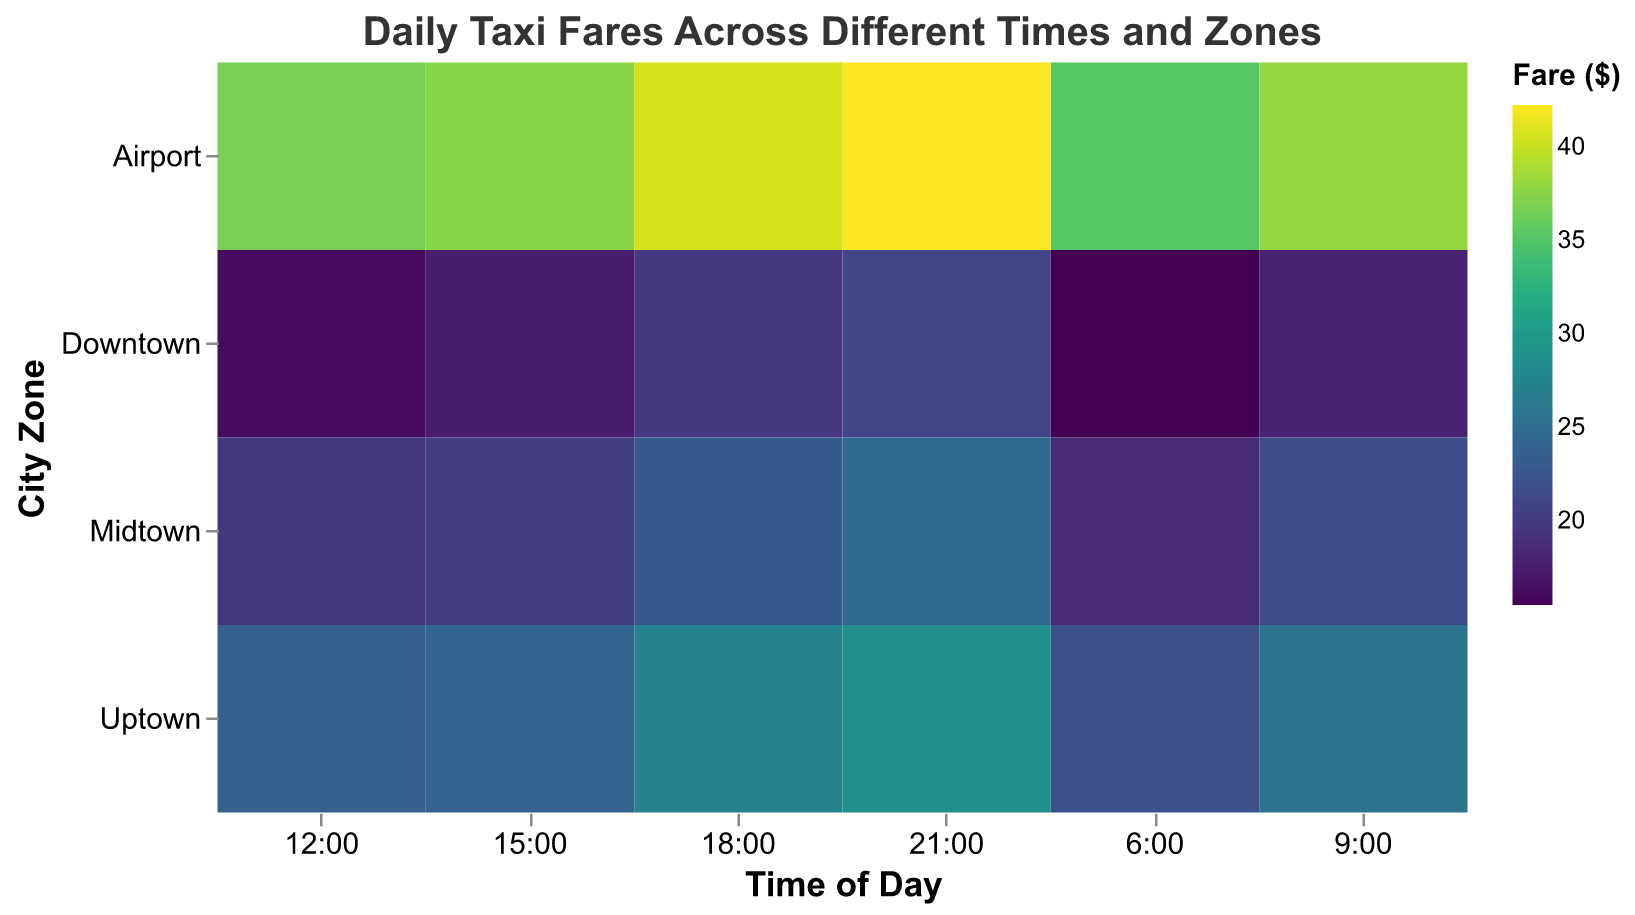What is the title of the figure? The title is usually placed at the top of the chart. In this figure, it is written as "Daily Taxi Fares Across Different Times and Zones."
Answer: Daily Taxi Fares Across Different Times and Zones How many time points are included in the data? Look at the X-axis, which represents the time of day; these time points are: 6:00, 9:00, 12:00, 15:00, 18:00, and 21:00. Count these points.
Answer: 6 Which time period has the highest fare in the Airport zone? In the Y-axis zones, search for "Airport," then across the X-axis time slots, find the highest fare number in the "Airport" row. The highest value is 42.25 at 21:00.
Answer: 21:00 What is the difference in fares between Downtown and Midtown at 18:00? Identify the fares for Downtown and Midtown at 18:00. Downtown is $19.75, Midtown is $23.00. The difference is $23.00 - $19.75.
Answer: 3.25 At what time of day is the fare highest for the Uptown zone? Scan the Uptown row's fare values for all time points and identify the highest. The highest fare for Uptown is $28.75 at 21:00.
Answer: 21:00 Which zone and time combination has the lowest fare? Examine the entire data matrix; the goal is finding the lowest fare number in the entire chart, 15.50, which is at 6:00 in the Downtown zone.
Answer: Downtown at 6:00 How does the fare change in the Downtown zone from 6:00 to 21:00? Trace the Downtown zone row visually across the time points from start (6:00 at $15.50) to end (21:00 at $21.00). Compare each fare: it generally increases over time.
Answer: Increases Compare the fares at 12:00 and 15:00 in the Midtown zone. Which time has a higher fare? Check the Midtown row's fare at 12:00 ($19.75) and 15:00 ($20.25). Compare these values.
Answer: 15:00 Calculate the average fare for Uptown throughout the day. Add up all fares for Uptown: $22.00 (6:00) + $25.75 (9:00) + $23.50 (12:00) + $24.00 (15:00) + $27.25 (18:00) + $28.75 (21:00) = $151.25. Divide by 6 (number of time points).
Answer: 25.21 